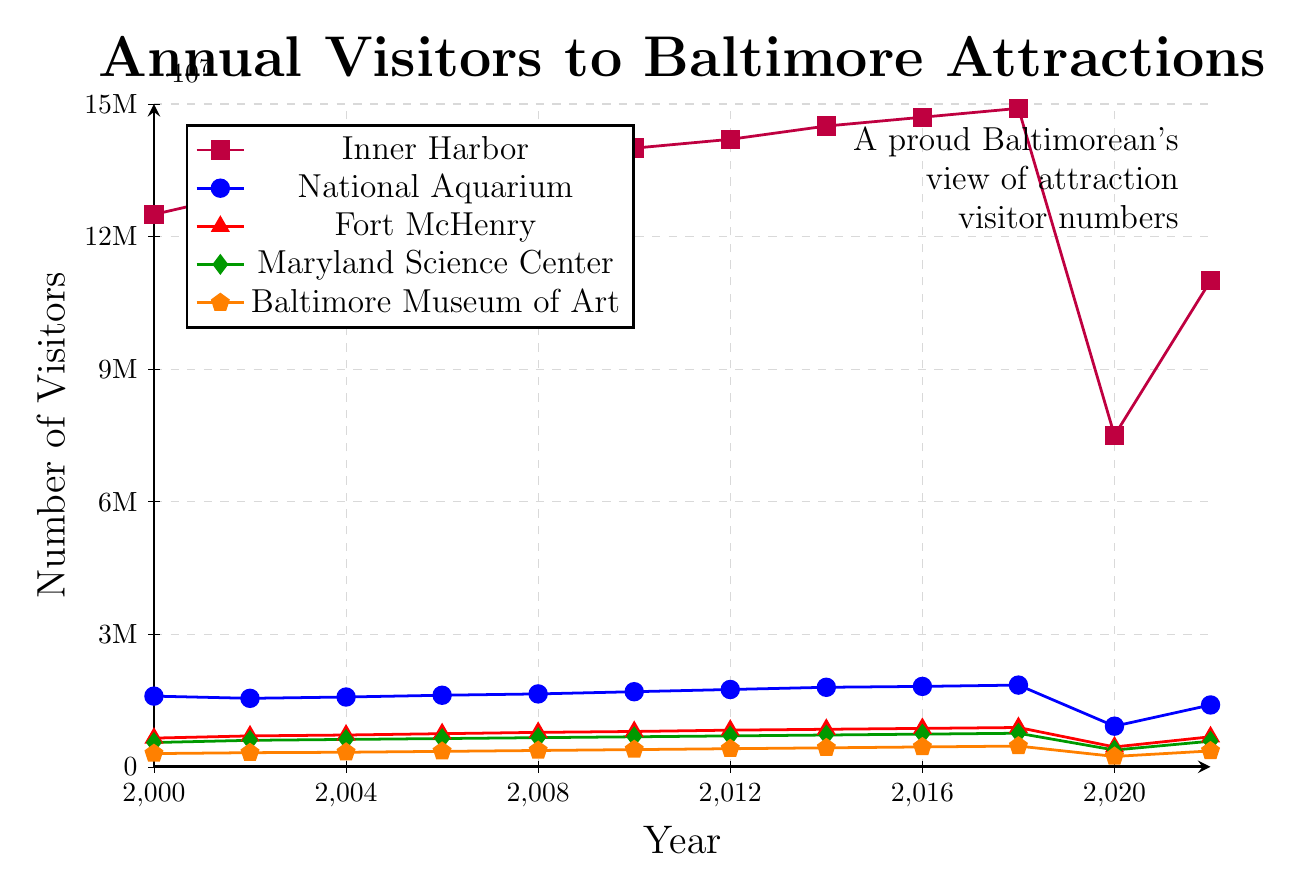Which attraction had the highest number of visitors in 2010? To find the highest number of visitors in 2010, refer to the data points corresponding to 2010 for each attraction and compare them. Inner Harbor had 14,000,000 visitors, which is higher than all the others.
Answer: Inner Harbor What was the trend in visitor numbers for the Inner Harbor from 2000 to 2018? Look at the line representing Inner Harbor from 2000 to 2018; it steadily increases from 12,500,000 in 2000 to 14,900,000 in 2018.
Answer: Increasing How did the visitor numbers for the National Aquarium change between 2018 and 2020? Compare the data points for the National Aquarium in 2018 and 2020. The visitor numbers decreased from 1,850,000 in 2018 to 920,000 in 2020.
Answer: Decreased Which year showed the sharpest decline in visitor numbers at the Inner Harbor? Look for the steepest drop in the line representing the Inner Harbor. The sharp decline was between 2018 (14,900,000) and 2020 (7,500,000).
Answer: 2020 Compare the visitor numbers in 2022 for the Baltimore Museum of Art and the Maryland Science Center. Locate the 2022 data for both attractions. The Baltimore Museum of Art had 360,000 visitors, while the Maryland Science Center had 580,000 visitors.
Answer: Maryland Science Center had more visitors How much did the visitors to Fort McHenry increase from 2000 to 2016? Calculate the difference between the numbers in 2016 (870,000) and 2000 (650,000). \(870,000 - 650,000 = 220,000\).
Answer: 220,000 What was the overall trend in visitor numbers to Baltimore attractions in 2020? Observe all the lines on the graph for each attraction in 2020. They all show a significant drop in visitor numbers.
Answer: Decline Which attraction had the least visitors in 2000 and how many did it have? Compare the 2000 data points for all attractions. The Baltimore Museum of Art had the least visitors with 300,000.
Answer: Baltimore Museum of Art, 300,000 Calculate the average number of visitors for the National Aquarium between 2010 and 2018. Add the visitor numbers between 2010 (1,700,000) and 2018 (1,850,000), and divide by 5 (the number of data points). \((1,700,000 + 1,750,000 + 1,800,000 + 1,820,000 + 1,850,000) / 5 = 1,784,000\).
Answer: 1,784,000 